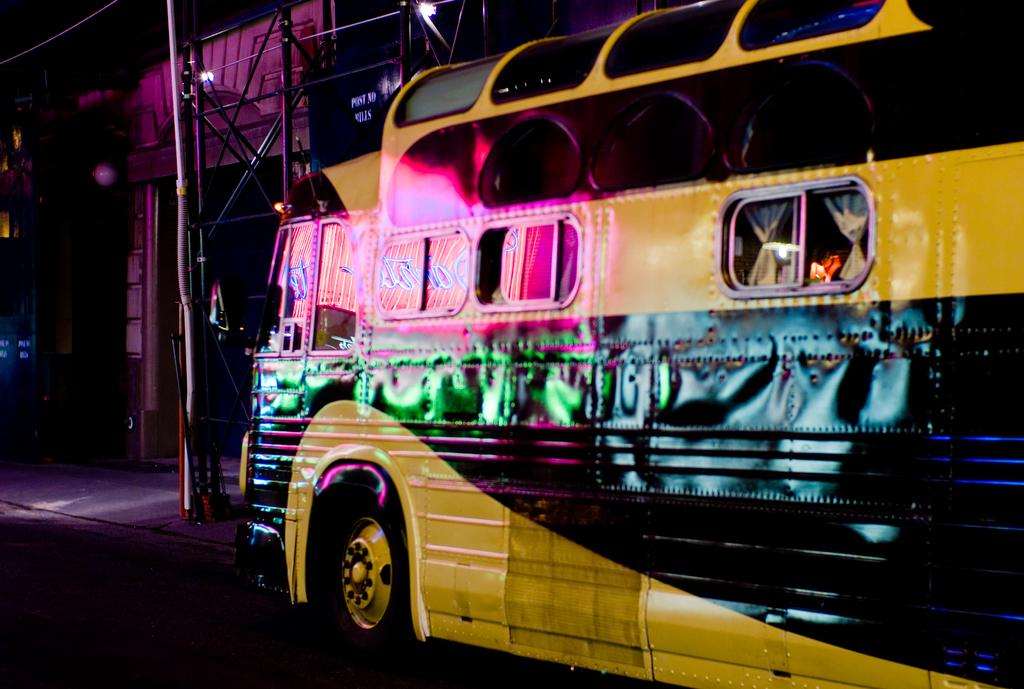What type of structure is visible in the image? There is a building in the image. What else can be seen on the road in the image? There is a vehicle on the road in the image. What is in front of the building in the image? There are poles in front of the building in the image. What is at the top of the poles in the image? There is a wire at the top in the image. What is located near the road in the image? There is a footpath near the road in the image. How would you describe the lighting in the image? The background of the image is dark. How many mouths can be seen on the building in the image? There are no mouths present on the building in the image. What type of arch is visible in the image? There is no arch visible in the image. 